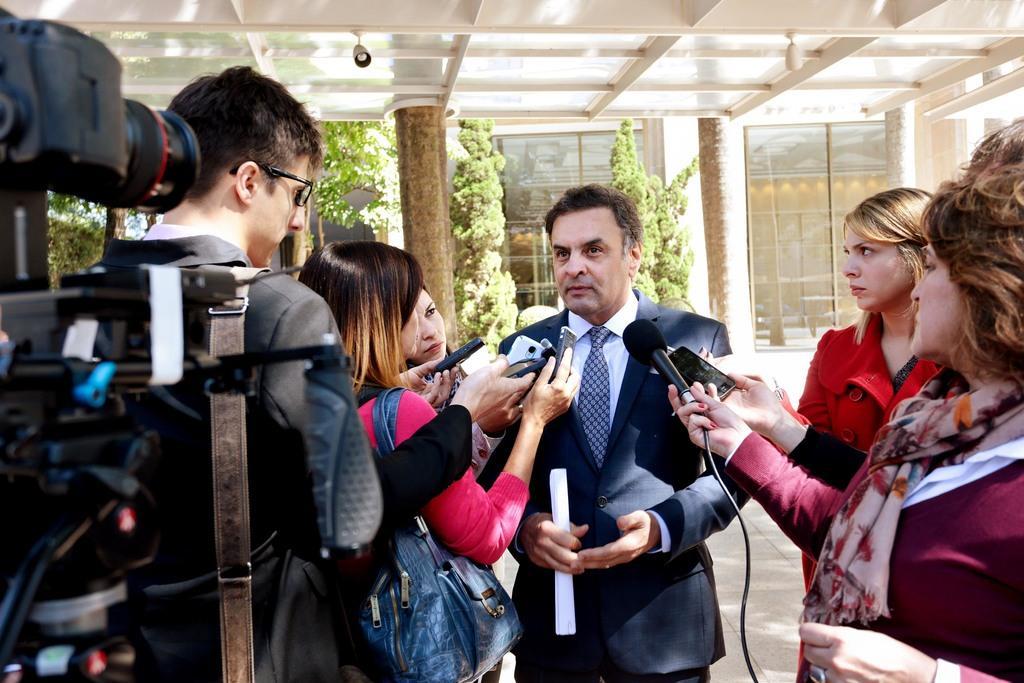Can you describe this image briefly? In this picture there is a person wearing suit is standing and holding a paper in his hands and there are few people standing in front of him are holding a mic and few mobiles and there is a camera in the left corner and there is a building and few plants in the background. 